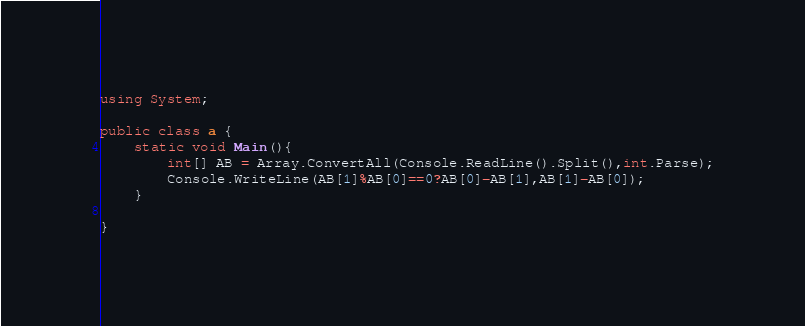<code> <loc_0><loc_0><loc_500><loc_500><_C#_>using System;

public class a {
	static void Main(){
    	int[] AB = Array.ConvertAll(Console.ReadLine().Split(),int.Parse);
      	Console.WriteLine(AB[1]%AB[0]==0?AB[0]-AB[1],AB[1]-AB[0]);
    }

}
</code> 